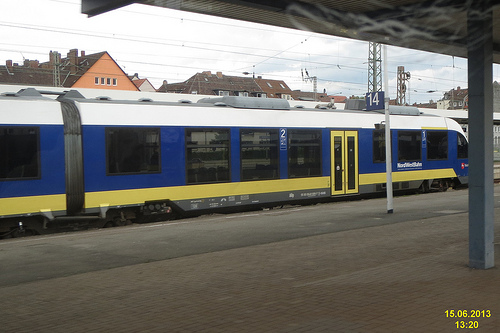Is the tower that is to the right of the other tower made of brick? No, the tower to the right does not appear to be made of brick; it looks to have a smooth facade unlike the texture of brick. 